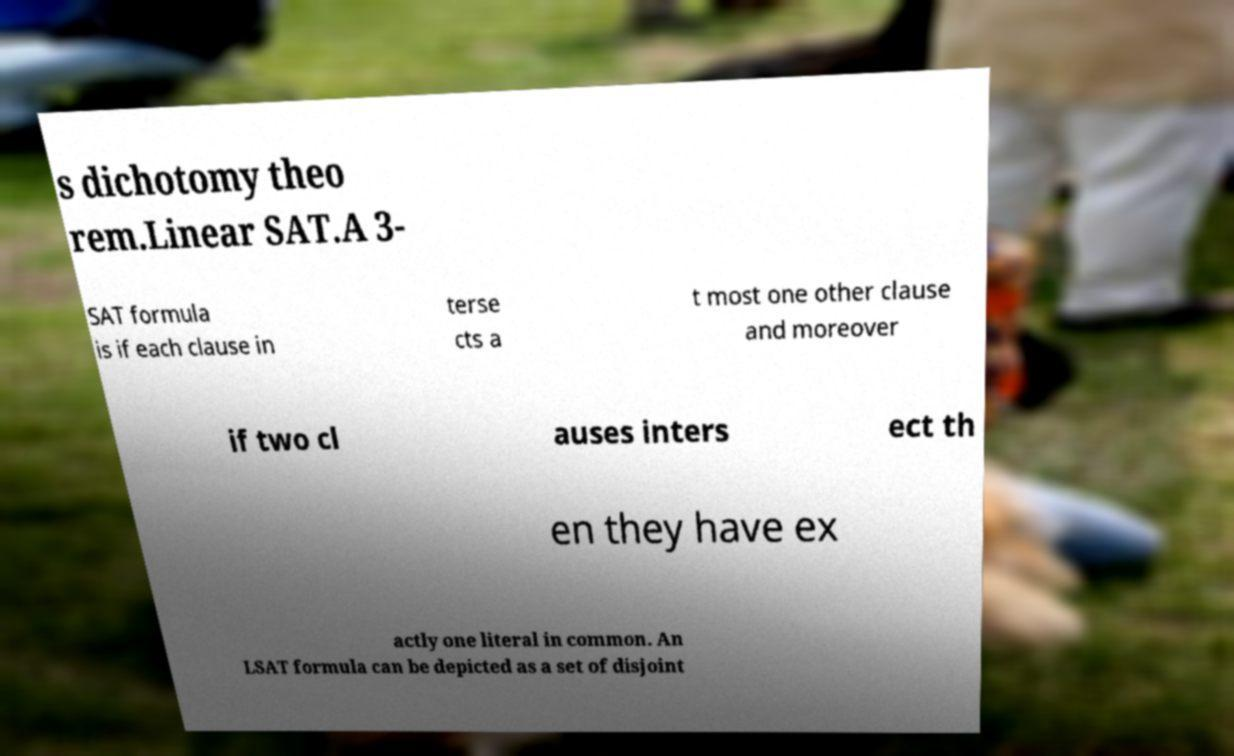Could you assist in decoding the text presented in this image and type it out clearly? s dichotomy theo rem.Linear SAT.A 3- SAT formula is if each clause in terse cts a t most one other clause and moreover if two cl auses inters ect th en they have ex actly one literal in common. An LSAT formula can be depicted as a set of disjoint 